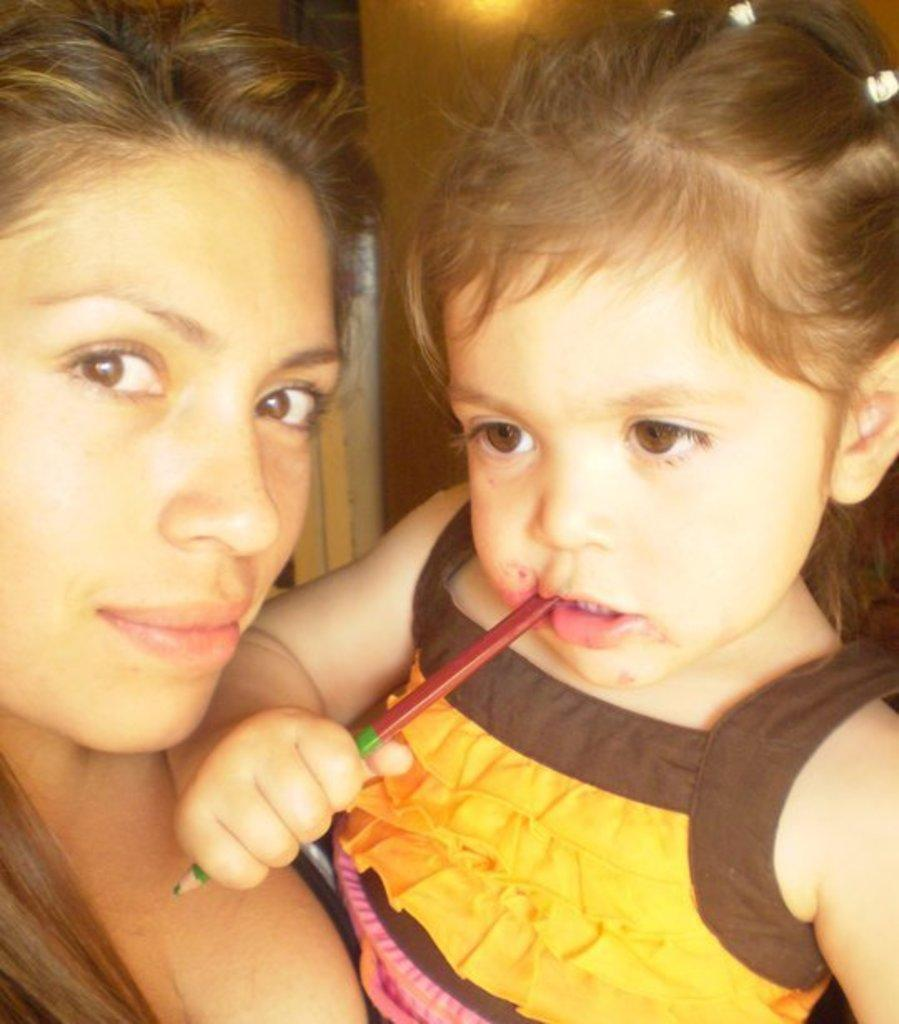Who is the main subject in the image? There is a woman in the image. What is the woman doing in the image? The woman is standing in the front and holding a small girl. What is the woman's expression in the image? The woman is smiling in the image. What is the woman doing with her body in the image? The woman is giving a pose to the camera. What type of cast is visible on the woman's arm in the image? There is no cast visible on the woman's arm in the image. What kind of club does the woman belong to in the image? There is no club mentioned or visible in the image. 